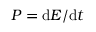<formula> <loc_0><loc_0><loc_500><loc_500>P = d E / d t</formula> 